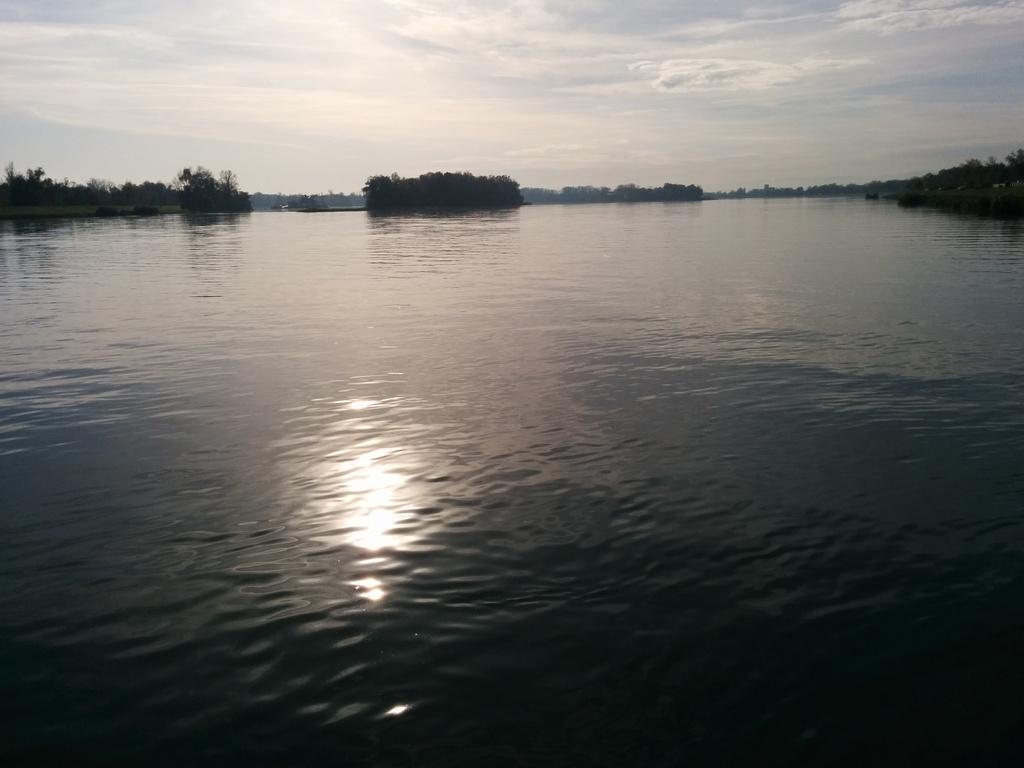Can you describe this image briefly? In this picture we can see water and trees and in the background we can see the sky. 